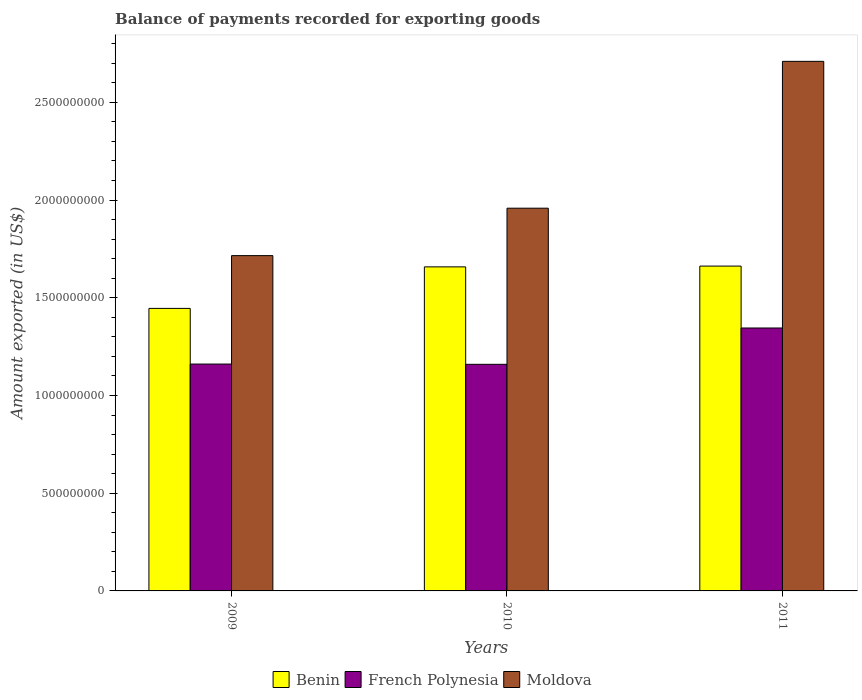How many different coloured bars are there?
Your answer should be compact. 3. How many groups of bars are there?
Make the answer very short. 3. Are the number of bars per tick equal to the number of legend labels?
Offer a terse response. Yes. How many bars are there on the 2nd tick from the left?
Give a very brief answer. 3. How many bars are there on the 3rd tick from the right?
Keep it short and to the point. 3. What is the label of the 2nd group of bars from the left?
Make the answer very short. 2010. What is the amount exported in Moldova in 2010?
Provide a succinct answer. 1.96e+09. Across all years, what is the maximum amount exported in French Polynesia?
Your answer should be very brief. 1.35e+09. Across all years, what is the minimum amount exported in Benin?
Your answer should be very brief. 1.45e+09. In which year was the amount exported in French Polynesia minimum?
Your answer should be compact. 2010. What is the total amount exported in Benin in the graph?
Provide a short and direct response. 4.77e+09. What is the difference between the amount exported in Moldova in 2010 and that in 2011?
Give a very brief answer. -7.51e+08. What is the difference between the amount exported in Benin in 2011 and the amount exported in Moldova in 2010?
Offer a terse response. -2.96e+08. What is the average amount exported in Benin per year?
Make the answer very short. 1.59e+09. In the year 2010, what is the difference between the amount exported in Benin and amount exported in French Polynesia?
Provide a succinct answer. 4.99e+08. In how many years, is the amount exported in Moldova greater than 1700000000 US$?
Offer a very short reply. 3. What is the ratio of the amount exported in French Polynesia in 2009 to that in 2010?
Offer a terse response. 1. What is the difference between the highest and the second highest amount exported in Moldova?
Offer a terse response. 7.51e+08. What is the difference between the highest and the lowest amount exported in Benin?
Give a very brief answer. 2.16e+08. In how many years, is the amount exported in French Polynesia greater than the average amount exported in French Polynesia taken over all years?
Your answer should be compact. 1. Is the sum of the amount exported in Moldova in 2009 and 2010 greater than the maximum amount exported in French Polynesia across all years?
Offer a terse response. Yes. What does the 3rd bar from the left in 2011 represents?
Keep it short and to the point. Moldova. What does the 2nd bar from the right in 2009 represents?
Your answer should be compact. French Polynesia. How many bars are there?
Offer a very short reply. 9. Does the graph contain any zero values?
Give a very brief answer. No. Does the graph contain grids?
Make the answer very short. No. Where does the legend appear in the graph?
Your response must be concise. Bottom center. How many legend labels are there?
Make the answer very short. 3. How are the legend labels stacked?
Give a very brief answer. Horizontal. What is the title of the graph?
Provide a short and direct response. Balance of payments recorded for exporting goods. Does "Channel Islands" appear as one of the legend labels in the graph?
Your response must be concise. No. What is the label or title of the X-axis?
Keep it short and to the point. Years. What is the label or title of the Y-axis?
Provide a short and direct response. Amount exported (in US$). What is the Amount exported (in US$) of Benin in 2009?
Provide a succinct answer. 1.45e+09. What is the Amount exported (in US$) in French Polynesia in 2009?
Ensure brevity in your answer.  1.16e+09. What is the Amount exported (in US$) of Moldova in 2009?
Provide a succinct answer. 1.72e+09. What is the Amount exported (in US$) in Benin in 2010?
Your response must be concise. 1.66e+09. What is the Amount exported (in US$) of French Polynesia in 2010?
Your response must be concise. 1.16e+09. What is the Amount exported (in US$) in Moldova in 2010?
Provide a short and direct response. 1.96e+09. What is the Amount exported (in US$) of Benin in 2011?
Offer a terse response. 1.66e+09. What is the Amount exported (in US$) in French Polynesia in 2011?
Your answer should be compact. 1.35e+09. What is the Amount exported (in US$) of Moldova in 2011?
Your answer should be very brief. 2.71e+09. Across all years, what is the maximum Amount exported (in US$) in Benin?
Your answer should be compact. 1.66e+09. Across all years, what is the maximum Amount exported (in US$) of French Polynesia?
Offer a very short reply. 1.35e+09. Across all years, what is the maximum Amount exported (in US$) in Moldova?
Offer a very short reply. 2.71e+09. Across all years, what is the minimum Amount exported (in US$) of Benin?
Your answer should be very brief. 1.45e+09. Across all years, what is the minimum Amount exported (in US$) in French Polynesia?
Your answer should be very brief. 1.16e+09. Across all years, what is the minimum Amount exported (in US$) in Moldova?
Offer a terse response. 1.72e+09. What is the total Amount exported (in US$) in Benin in the graph?
Provide a succinct answer. 4.77e+09. What is the total Amount exported (in US$) of French Polynesia in the graph?
Keep it short and to the point. 3.67e+09. What is the total Amount exported (in US$) in Moldova in the graph?
Your answer should be compact. 6.38e+09. What is the difference between the Amount exported (in US$) of Benin in 2009 and that in 2010?
Offer a terse response. -2.12e+08. What is the difference between the Amount exported (in US$) of French Polynesia in 2009 and that in 2010?
Keep it short and to the point. 1.39e+06. What is the difference between the Amount exported (in US$) of Moldova in 2009 and that in 2010?
Your response must be concise. -2.43e+08. What is the difference between the Amount exported (in US$) of Benin in 2009 and that in 2011?
Keep it short and to the point. -2.16e+08. What is the difference between the Amount exported (in US$) in French Polynesia in 2009 and that in 2011?
Offer a terse response. -1.84e+08. What is the difference between the Amount exported (in US$) in Moldova in 2009 and that in 2011?
Make the answer very short. -9.94e+08. What is the difference between the Amount exported (in US$) of Benin in 2010 and that in 2011?
Keep it short and to the point. -3.97e+06. What is the difference between the Amount exported (in US$) of French Polynesia in 2010 and that in 2011?
Your answer should be very brief. -1.86e+08. What is the difference between the Amount exported (in US$) of Moldova in 2010 and that in 2011?
Provide a short and direct response. -7.51e+08. What is the difference between the Amount exported (in US$) in Benin in 2009 and the Amount exported (in US$) in French Polynesia in 2010?
Offer a terse response. 2.86e+08. What is the difference between the Amount exported (in US$) in Benin in 2009 and the Amount exported (in US$) in Moldova in 2010?
Make the answer very short. -5.13e+08. What is the difference between the Amount exported (in US$) in French Polynesia in 2009 and the Amount exported (in US$) in Moldova in 2010?
Provide a short and direct response. -7.97e+08. What is the difference between the Amount exported (in US$) of Benin in 2009 and the Amount exported (in US$) of French Polynesia in 2011?
Provide a short and direct response. 1.00e+08. What is the difference between the Amount exported (in US$) in Benin in 2009 and the Amount exported (in US$) in Moldova in 2011?
Make the answer very short. -1.26e+09. What is the difference between the Amount exported (in US$) in French Polynesia in 2009 and the Amount exported (in US$) in Moldova in 2011?
Give a very brief answer. -1.55e+09. What is the difference between the Amount exported (in US$) in Benin in 2010 and the Amount exported (in US$) in French Polynesia in 2011?
Make the answer very short. 3.13e+08. What is the difference between the Amount exported (in US$) of Benin in 2010 and the Amount exported (in US$) of Moldova in 2011?
Give a very brief answer. -1.05e+09. What is the difference between the Amount exported (in US$) in French Polynesia in 2010 and the Amount exported (in US$) in Moldova in 2011?
Ensure brevity in your answer.  -1.55e+09. What is the average Amount exported (in US$) in Benin per year?
Provide a succinct answer. 1.59e+09. What is the average Amount exported (in US$) of French Polynesia per year?
Your answer should be very brief. 1.22e+09. What is the average Amount exported (in US$) in Moldova per year?
Provide a short and direct response. 2.13e+09. In the year 2009, what is the difference between the Amount exported (in US$) of Benin and Amount exported (in US$) of French Polynesia?
Offer a very short reply. 2.85e+08. In the year 2009, what is the difference between the Amount exported (in US$) in Benin and Amount exported (in US$) in Moldova?
Make the answer very short. -2.70e+08. In the year 2009, what is the difference between the Amount exported (in US$) of French Polynesia and Amount exported (in US$) of Moldova?
Ensure brevity in your answer.  -5.55e+08. In the year 2010, what is the difference between the Amount exported (in US$) in Benin and Amount exported (in US$) in French Polynesia?
Your answer should be compact. 4.99e+08. In the year 2010, what is the difference between the Amount exported (in US$) in Benin and Amount exported (in US$) in Moldova?
Offer a very short reply. -3.00e+08. In the year 2010, what is the difference between the Amount exported (in US$) of French Polynesia and Amount exported (in US$) of Moldova?
Your answer should be compact. -7.99e+08. In the year 2011, what is the difference between the Amount exported (in US$) in Benin and Amount exported (in US$) in French Polynesia?
Your answer should be very brief. 3.17e+08. In the year 2011, what is the difference between the Amount exported (in US$) of Benin and Amount exported (in US$) of Moldova?
Give a very brief answer. -1.05e+09. In the year 2011, what is the difference between the Amount exported (in US$) of French Polynesia and Amount exported (in US$) of Moldova?
Offer a very short reply. -1.36e+09. What is the ratio of the Amount exported (in US$) in Benin in 2009 to that in 2010?
Your response must be concise. 0.87. What is the ratio of the Amount exported (in US$) of French Polynesia in 2009 to that in 2010?
Make the answer very short. 1. What is the ratio of the Amount exported (in US$) in Moldova in 2009 to that in 2010?
Offer a terse response. 0.88. What is the ratio of the Amount exported (in US$) in Benin in 2009 to that in 2011?
Ensure brevity in your answer.  0.87. What is the ratio of the Amount exported (in US$) in French Polynesia in 2009 to that in 2011?
Offer a very short reply. 0.86. What is the ratio of the Amount exported (in US$) in Moldova in 2009 to that in 2011?
Provide a short and direct response. 0.63. What is the ratio of the Amount exported (in US$) of French Polynesia in 2010 to that in 2011?
Provide a succinct answer. 0.86. What is the ratio of the Amount exported (in US$) of Moldova in 2010 to that in 2011?
Your answer should be very brief. 0.72. What is the difference between the highest and the second highest Amount exported (in US$) in Benin?
Offer a very short reply. 3.97e+06. What is the difference between the highest and the second highest Amount exported (in US$) of French Polynesia?
Ensure brevity in your answer.  1.84e+08. What is the difference between the highest and the second highest Amount exported (in US$) of Moldova?
Offer a terse response. 7.51e+08. What is the difference between the highest and the lowest Amount exported (in US$) of Benin?
Your answer should be very brief. 2.16e+08. What is the difference between the highest and the lowest Amount exported (in US$) of French Polynesia?
Your response must be concise. 1.86e+08. What is the difference between the highest and the lowest Amount exported (in US$) of Moldova?
Offer a very short reply. 9.94e+08. 